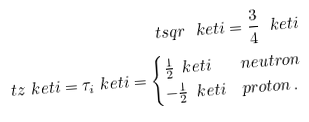Convert formula to latex. <formula><loc_0><loc_0><loc_500><loc_500>\ t s q r \ k e t { i } = \frac { 3 } { 4 } \ k e t { i } \\ \ t z \ k e t { i } = \tau _ { i } \ k e t { i } = \begin{cases} \frac { 1 } { 2 } \, \ k e t { i } & n e u t r o n \\ - \frac { 1 } { 2 } \, \ k e t { i } & p r o t o n \, . \end{cases}</formula> 